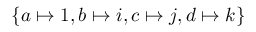Convert formula to latex. <formula><loc_0><loc_0><loc_500><loc_500>\{ a \mapsto 1 , b \mapsto i , c \mapsto j , d \mapsto k \}</formula> 